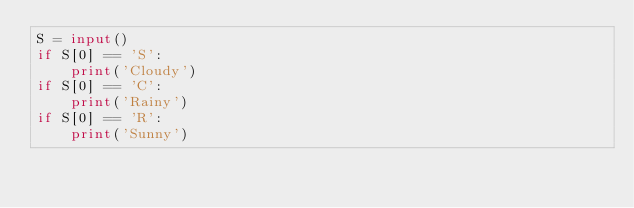Convert code to text. <code><loc_0><loc_0><loc_500><loc_500><_Python_>S = input()
if S[0] == 'S':
    print('Cloudy')
if S[0] == 'C':
    print('Rainy')
if S[0] == 'R':
    print('Sunny')</code> 